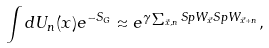Convert formula to latex. <formula><loc_0><loc_0><loc_500><loc_500>\int d U _ { n } ( x ) e ^ { - S _ { G } } \approx e ^ { \gamma \sum _ { \vec { x } , n } S p W _ { \vec { x } } S p W _ { \vec { x } + n } } ,</formula> 